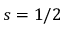Convert formula to latex. <formula><loc_0><loc_0><loc_500><loc_500>s = 1 / 2</formula> 